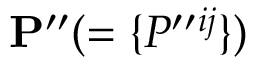Convert formula to latex. <formula><loc_0><loc_0><loc_500><loc_500>{ P } ^ { \prime \prime } ( = \{ { P ^ { \prime \prime ^ { i j } } \} )</formula> 